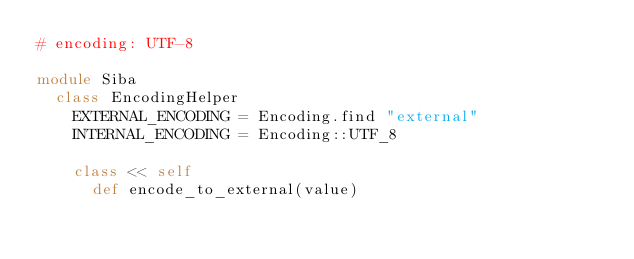Convert code to text. <code><loc_0><loc_0><loc_500><loc_500><_Ruby_># encoding: UTF-8

module Siba
  class EncodingHelper
    EXTERNAL_ENCODING = Encoding.find "external"
    INTERNAL_ENCODING = Encoding::UTF_8

    class << self
      def encode_to_external(value)</code> 